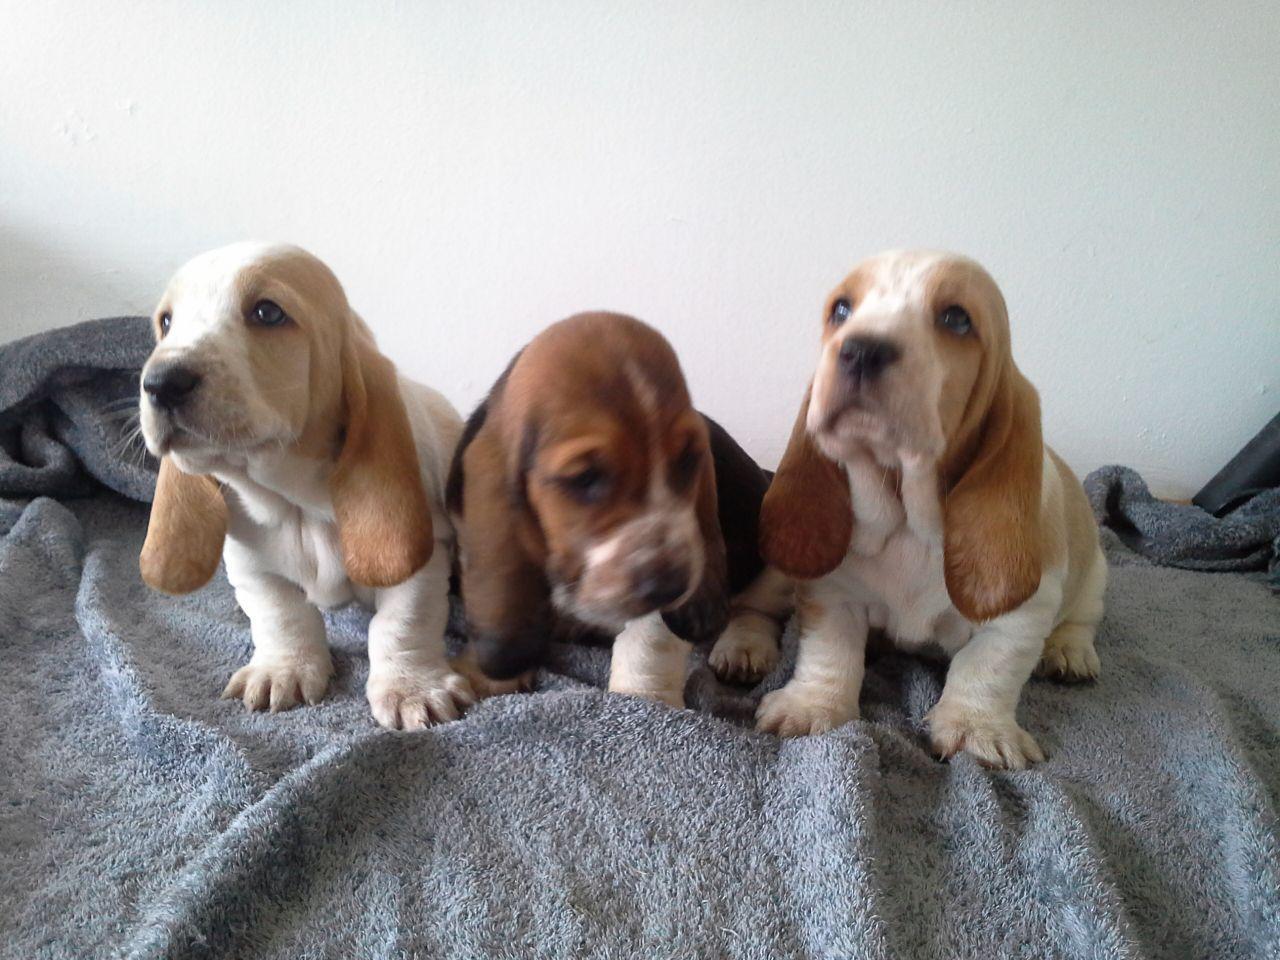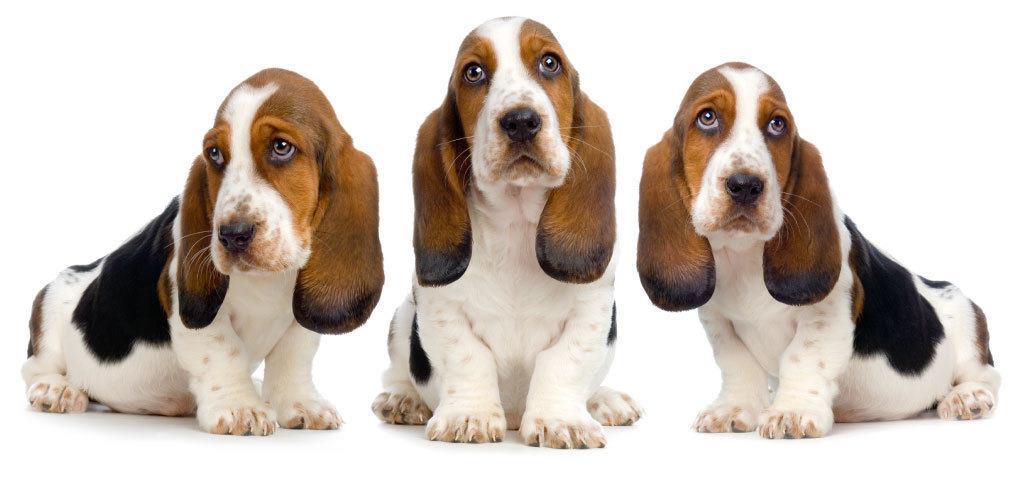The first image is the image on the left, the second image is the image on the right. Considering the images on both sides, is "There are no more than two dogs." valid? Answer yes or no. No. The first image is the image on the left, the second image is the image on the right. Evaluate the accuracy of this statement regarding the images: "Each image contains the same number of animals and contains more than one animal.". Is it true? Answer yes or no. Yes. 